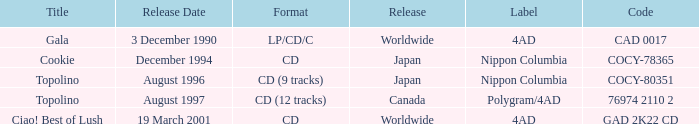Which record label published an album in august 1996? Nippon Columbia. 